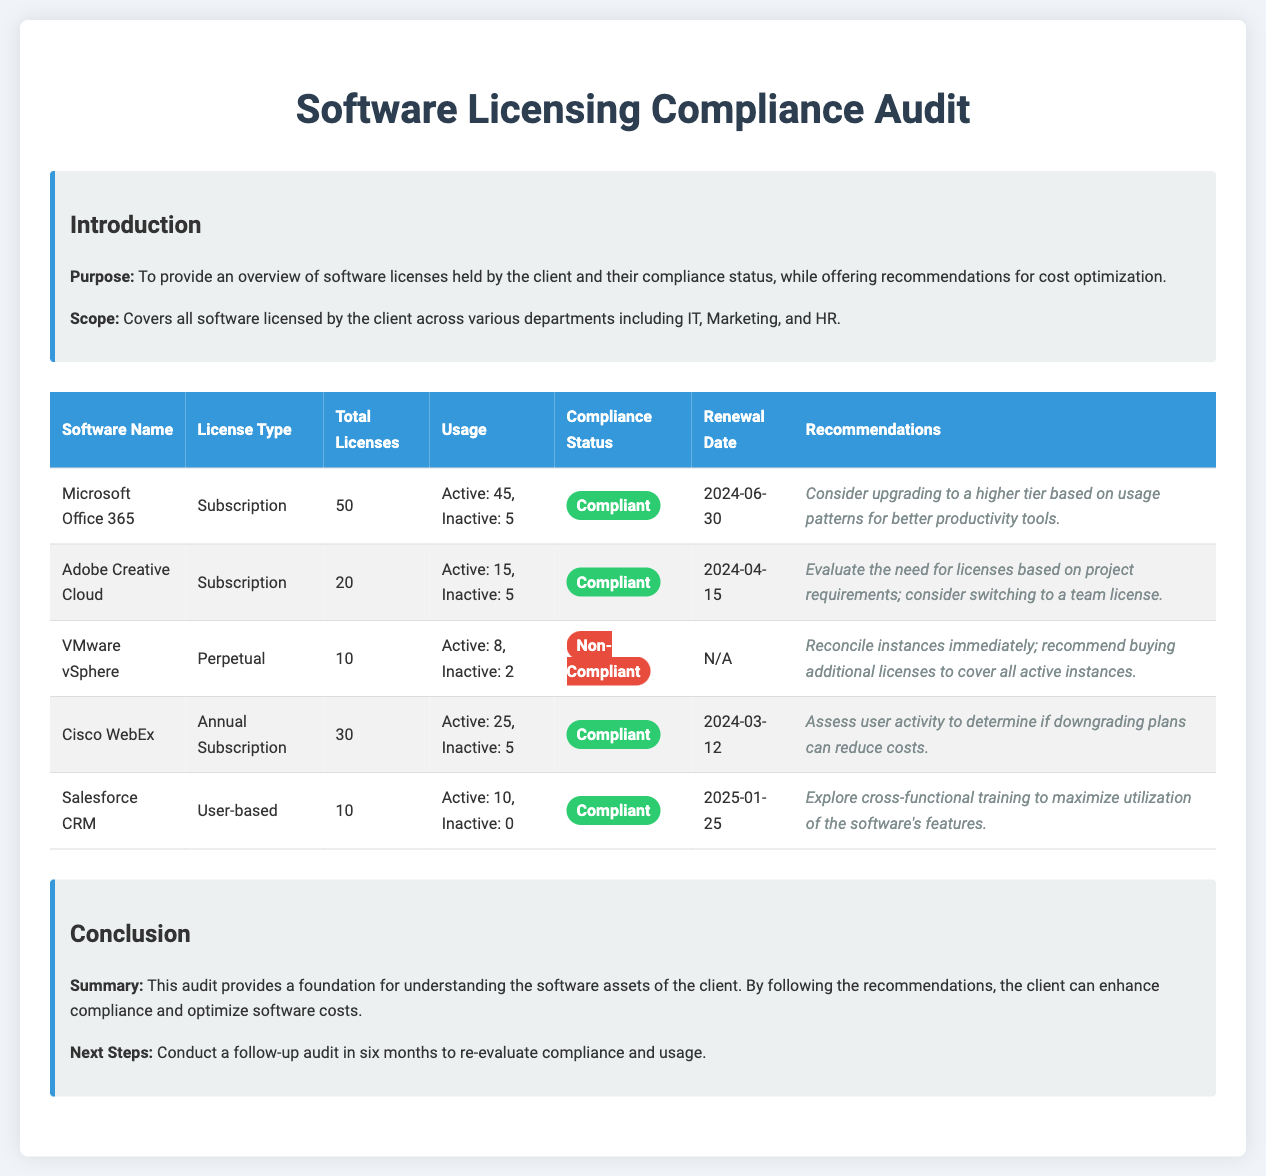what is the total number of Microsoft Office 365 licenses? The document states that there are 50 total licenses for Microsoft Office 365.
Answer: 50 what is the compliance status of VMware vSphere? The document indicates that the compliance status of VMware vSphere is non-compliant.
Answer: Non-Compliant when is the renewal date for Adobe Creative Cloud? According to the document, the renewal date for Adobe Creative Cloud is April 15, 2024.
Answer: 2024-04-15 how many active licenses does Cisco WebEx have? The document specifies that there are 25 active licenses for Cisco WebEx.
Answer: 25 what recommendation is given for Salesforce CRM? The document recommends to explore cross-functional training to maximize utilization of the software's features.
Answer: Explore cross-functional training to maximize utilization of the software's features what is the purpose of this audit document? The document states that the purpose is to provide an overview of software licenses and their compliance status.
Answer: Provide an overview of software licenses and their compliance status how many total licenses does Adobe Creative Cloud have? The total number of licenses for Adobe Creative Cloud, as mentioned in the document, is 20.
Answer: 20 what is the status label color for compliant software? The compliant software status label in the document is colored in green.
Answer: Green 